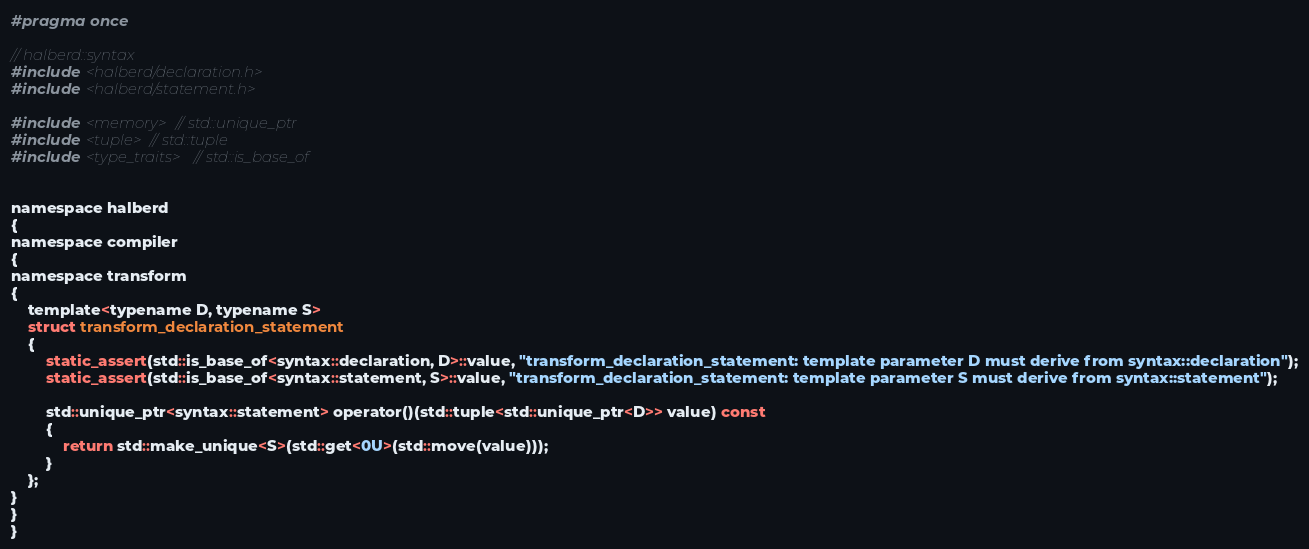<code> <loc_0><loc_0><loc_500><loc_500><_C_>#pragma once

// halberd::syntax
#include <halberd/declaration.h>
#include <halberd/statement.h>

#include <memory> // std::unique_ptr
#include <tuple> // std::tuple
#include <type_traits> // std::is_base_of


namespace halberd
{
namespace compiler
{
namespace transform
{
    template<typename D, typename S>
    struct transform_declaration_statement
    {
        static_assert(std::is_base_of<syntax::declaration, D>::value, "transform_declaration_statement: template parameter D must derive from syntax::declaration");
        static_assert(std::is_base_of<syntax::statement, S>::value, "transform_declaration_statement: template parameter S must derive from syntax::statement");

        std::unique_ptr<syntax::statement> operator()(std::tuple<std::unique_ptr<D>> value) const
        {
            return std::make_unique<S>(std::get<0U>(std::move(value)));
        }
    };
}
}
}
</code> 